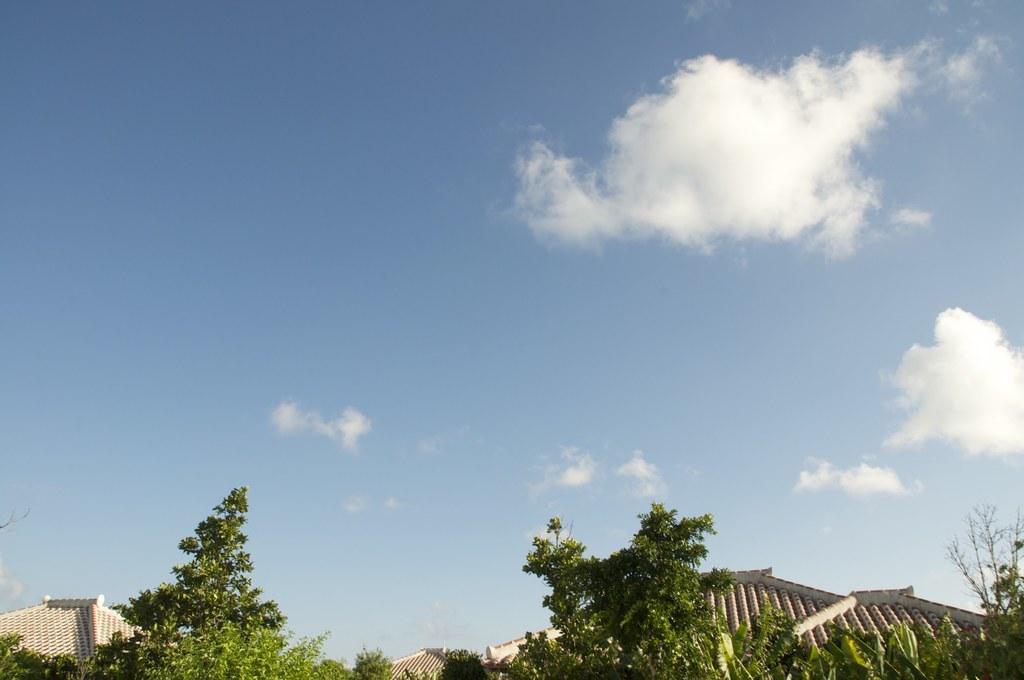How would you summarize this image in a sentence or two? In this image we can see some houses with roofs, trees and the sky which looks cloudy. 